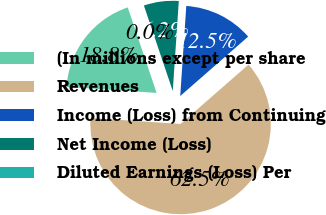Convert chart to OTSL. <chart><loc_0><loc_0><loc_500><loc_500><pie_chart><fcel>(In millions except per share<fcel>Revenues<fcel>Income (Loss) from Continuing<fcel>Net Income (Loss)<fcel>Diluted Earnings (Loss) Per<nl><fcel>18.75%<fcel>62.5%<fcel>12.5%<fcel>6.25%<fcel>0.0%<nl></chart> 